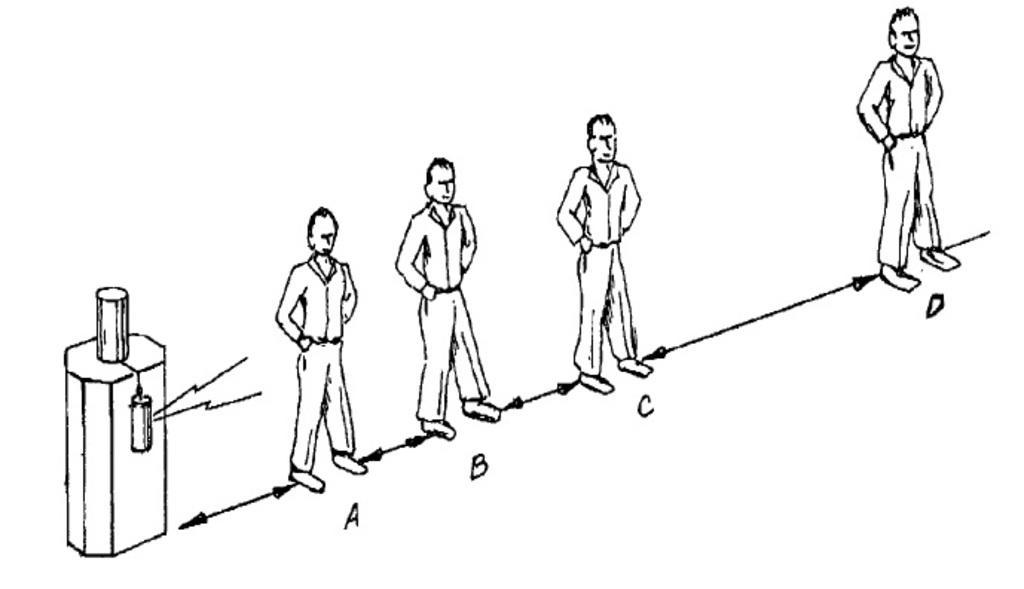In one or two sentences, can you explain what this image depicts? In the center of the image there are depictions of persons. 